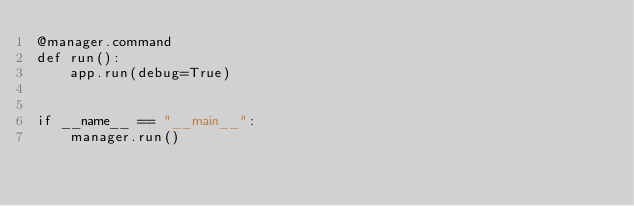Convert code to text. <code><loc_0><loc_0><loc_500><loc_500><_Python_>@manager.command
def run():
    app.run(debug=True)


if __name__ == "__main__":
    manager.run()
</code> 